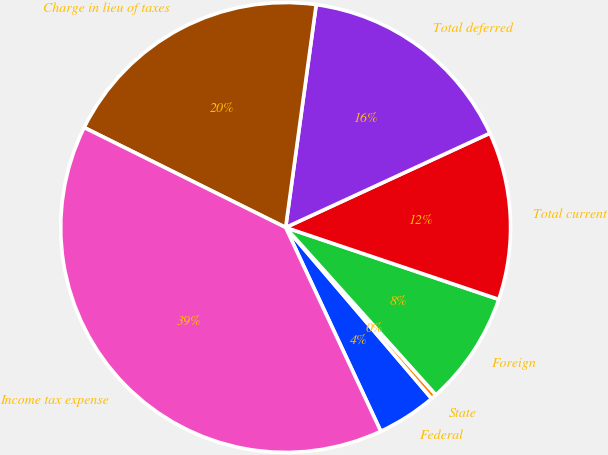Convert chart. <chart><loc_0><loc_0><loc_500><loc_500><pie_chart><fcel>Federal<fcel>State<fcel>Foreign<fcel>Total current<fcel>Total deferred<fcel>Charge in lieu of taxes<fcel>Income tax expense<nl><fcel>4.29%<fcel>0.4%<fcel>8.18%<fcel>12.06%<fcel>15.95%<fcel>19.84%<fcel>39.28%<nl></chart> 